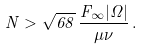Convert formula to latex. <formula><loc_0><loc_0><loc_500><loc_500>N > \sqrt { 6 8 } \, \frac { F _ { \infty } | \Omega | } { \mu \nu } \, .</formula> 